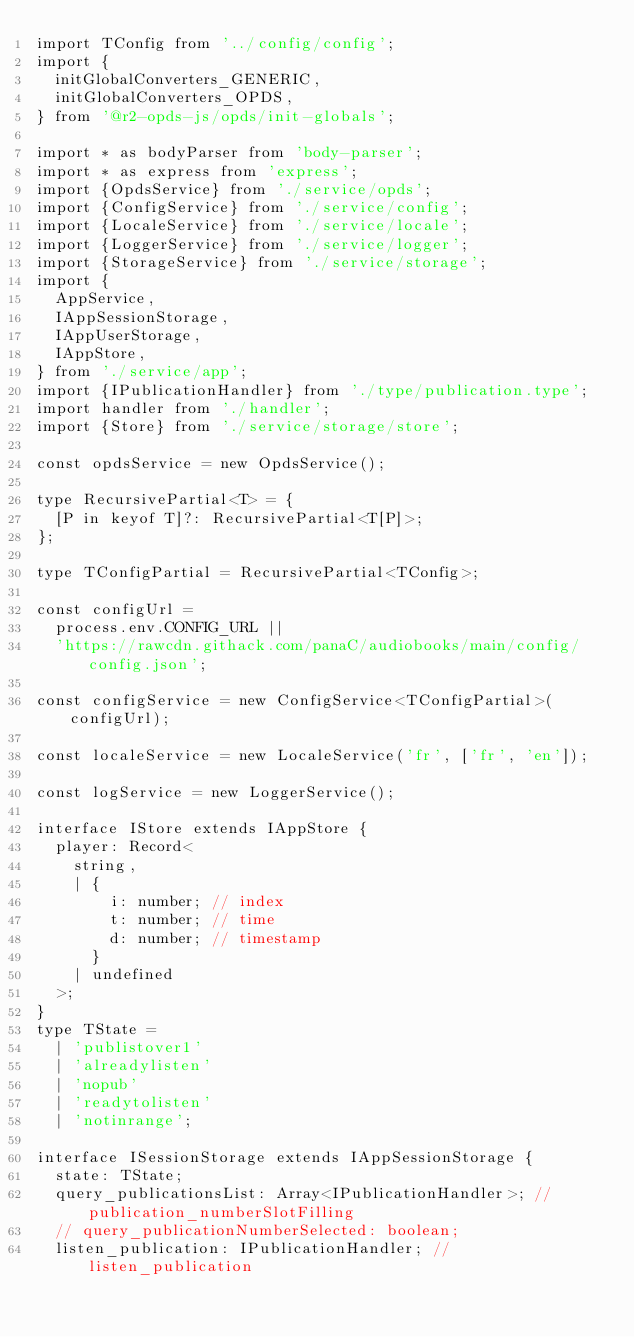<code> <loc_0><loc_0><loc_500><loc_500><_TypeScript_>import TConfig from '../config/config';
import {
  initGlobalConverters_GENERIC,
  initGlobalConverters_OPDS,
} from '@r2-opds-js/opds/init-globals';

import * as bodyParser from 'body-parser';
import * as express from 'express';
import {OpdsService} from './service/opds';
import {ConfigService} from './service/config';
import {LocaleService} from './service/locale';
import {LoggerService} from './service/logger';
import {StorageService} from './service/storage';
import {
  AppService,
  IAppSessionStorage,
  IAppUserStorage,
  IAppStore,
} from './service/app';
import {IPublicationHandler} from './type/publication.type';
import handler from './handler';
import {Store} from './service/storage/store';

const opdsService = new OpdsService();

type RecursivePartial<T> = {
  [P in keyof T]?: RecursivePartial<T[P]>;
};

type TConfigPartial = RecursivePartial<TConfig>;

const configUrl =
  process.env.CONFIG_URL ||
  'https://rawcdn.githack.com/panaC/audiobooks/main/config/config.json';

const configService = new ConfigService<TConfigPartial>(configUrl);

const localeService = new LocaleService('fr', ['fr', 'en']);

const logService = new LoggerService();

interface IStore extends IAppStore {
  player: Record<
    string,
    | {
        i: number; // index
        t: number; // time
        d: number; // timestamp
      }
    | undefined
  >;
}
type TState =
  | 'publistover1'
  | 'alreadylisten'
  | 'nopub'
  | 'readytolisten'
  | 'notinrange';

interface ISessionStorage extends IAppSessionStorage {
  state: TState;
  query_publicationsList: Array<IPublicationHandler>; // publication_numberSlotFilling
  // query_publicationNumberSelected: boolean;
  listen_publication: IPublicationHandler; // listen_publication</code> 